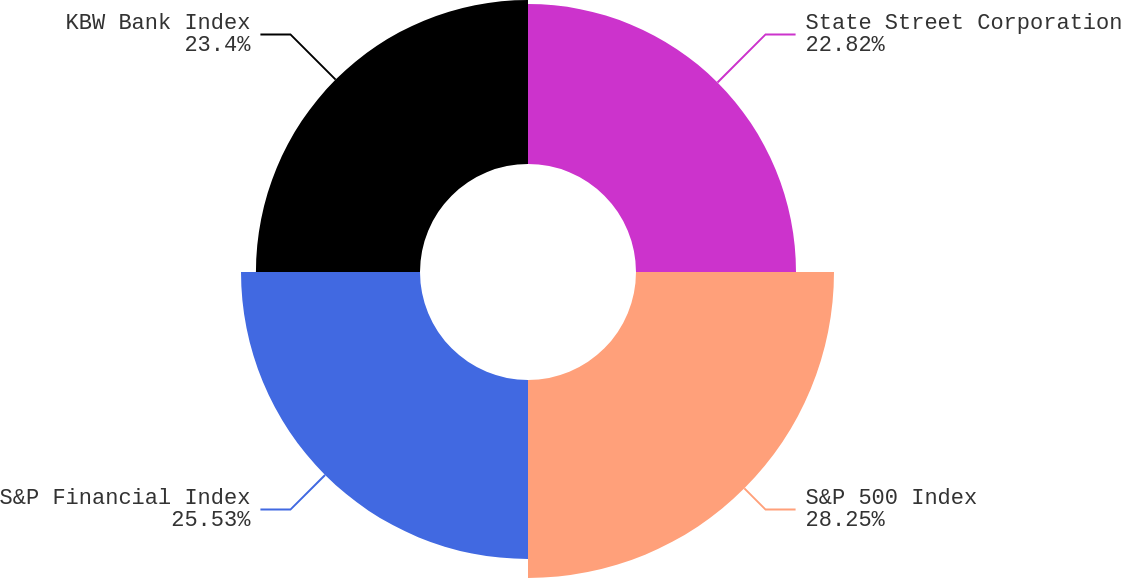Convert chart to OTSL. <chart><loc_0><loc_0><loc_500><loc_500><pie_chart><fcel>State Street Corporation<fcel>S&P 500 Index<fcel>S&P Financial Index<fcel>KBW Bank Index<nl><fcel>22.82%<fcel>28.24%<fcel>25.53%<fcel>23.4%<nl></chart> 